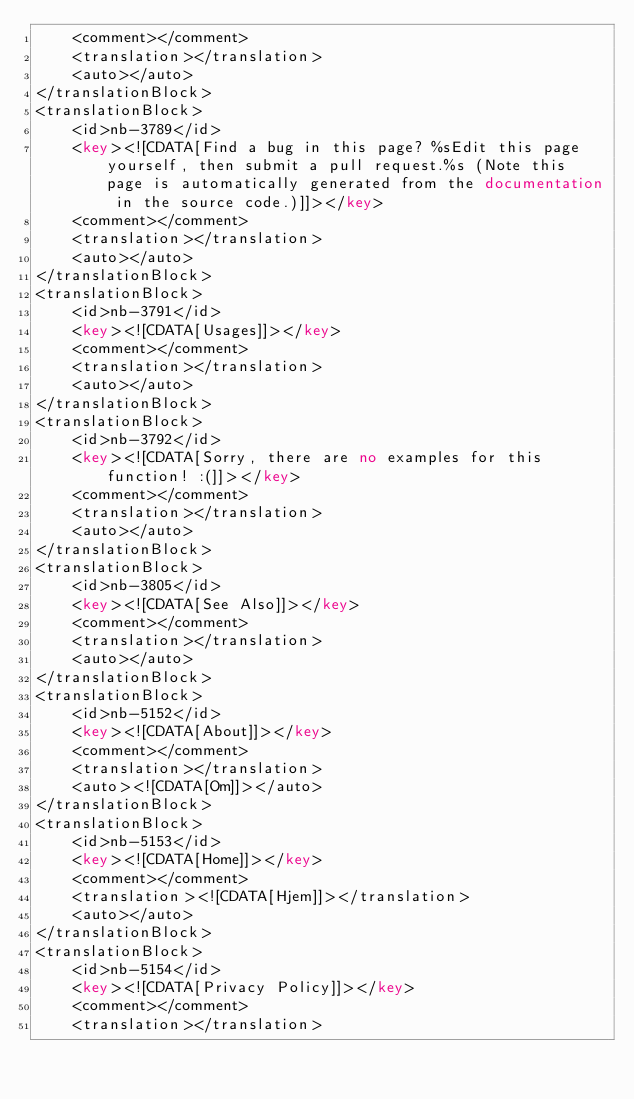Convert code to text. <code><loc_0><loc_0><loc_500><loc_500><_XML_>	<comment></comment>
	<translation></translation>
	<auto></auto>
</translationBlock>
<translationBlock>
	<id>nb-3789</id>
	<key><![CDATA[Find a bug in this page? %sEdit this page yourself, then submit a pull request.%s (Note this page is automatically generated from the documentation in the source code.)]]></key>
	<comment></comment>
	<translation></translation>
	<auto></auto>
</translationBlock>
<translationBlock>
	<id>nb-3791</id>
	<key><![CDATA[Usages]]></key>
	<comment></comment>
	<translation></translation>
	<auto></auto>
</translationBlock>
<translationBlock>
	<id>nb-3792</id>
	<key><![CDATA[Sorry, there are no examples for this function! :(]]></key>
	<comment></comment>
	<translation></translation>
	<auto></auto>
</translationBlock>
<translationBlock>
	<id>nb-3805</id>
	<key><![CDATA[See Also]]></key>
	<comment></comment>
	<translation></translation>
	<auto></auto>
</translationBlock>
<translationBlock>
	<id>nb-5152</id>
	<key><![CDATA[About]]></key>
	<comment></comment>
	<translation></translation>
	<auto><![CDATA[Om]]></auto>
</translationBlock>
<translationBlock>
	<id>nb-5153</id>
	<key><![CDATA[Home]]></key>
	<comment></comment>
	<translation><![CDATA[Hjem]]></translation>
	<auto></auto>
</translationBlock>
<translationBlock>
	<id>nb-5154</id>
	<key><![CDATA[Privacy Policy]]></key>
	<comment></comment>
	<translation></translation></code> 